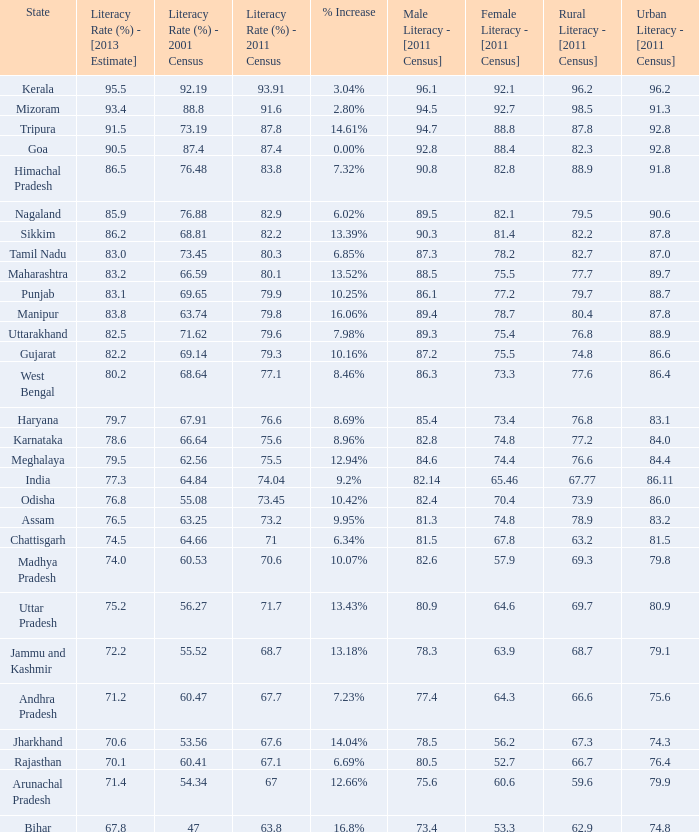What is the average increase in literacy for the states that had a rate higher than 73.2% in 2011, less than 68.81% in 2001, and an estimate of 76.8% for 2013? 10.42%. 